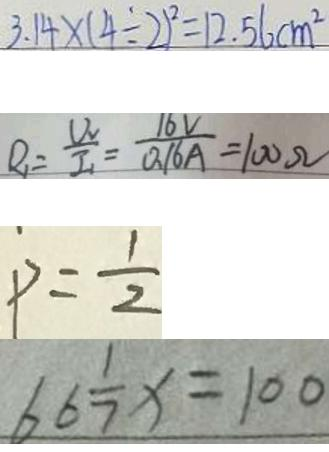Convert formula to latex. <formula><loc_0><loc_0><loc_500><loc_500>3 . 1 4 \times ( 4 \div 2 ) ^ { 2 } = 1 2 . 5 6 c m ^ { 2 } 
 R _ { 1 } = \frac { U _ { v } } { I _ { 1 } } = \frac { 1 6 V } { 0 . 1 6 A } = 1 0 0 \Omega 
 P = \frac { 1 } { 2 } 
 6 6 \frac { 1 } { 7 } x = 1 0 0</formula> 